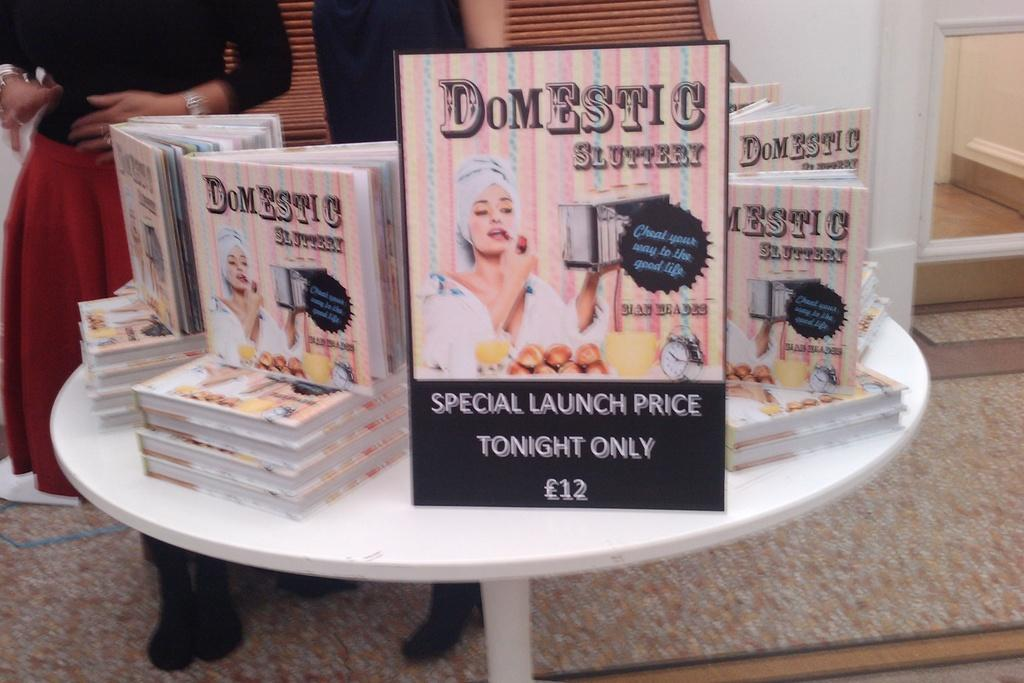What type of furniture is in the image? There is a white table in the image. What is on top of the table? The table has many books on it. Can you describe the lady in the image? The lady is wearing a black and red dress and is standing. Where might the lady be located in the image? The lady is standing near a door in the image. What type of park can be seen in the image? There is no park present in the image. How does the lady compare to the apparatus in the image? There is no apparatus present in the image for comparison. 